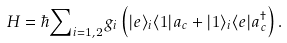Convert formula to latex. <formula><loc_0><loc_0><loc_500><loc_500>H = \hbar { \sum } _ { i = 1 , 2 } g _ { i } \left ( | e \rangle _ { i } \langle 1 | a _ { c } + | 1 \rangle _ { i } \langle e | a _ { c } ^ { \dag } \right ) .</formula> 